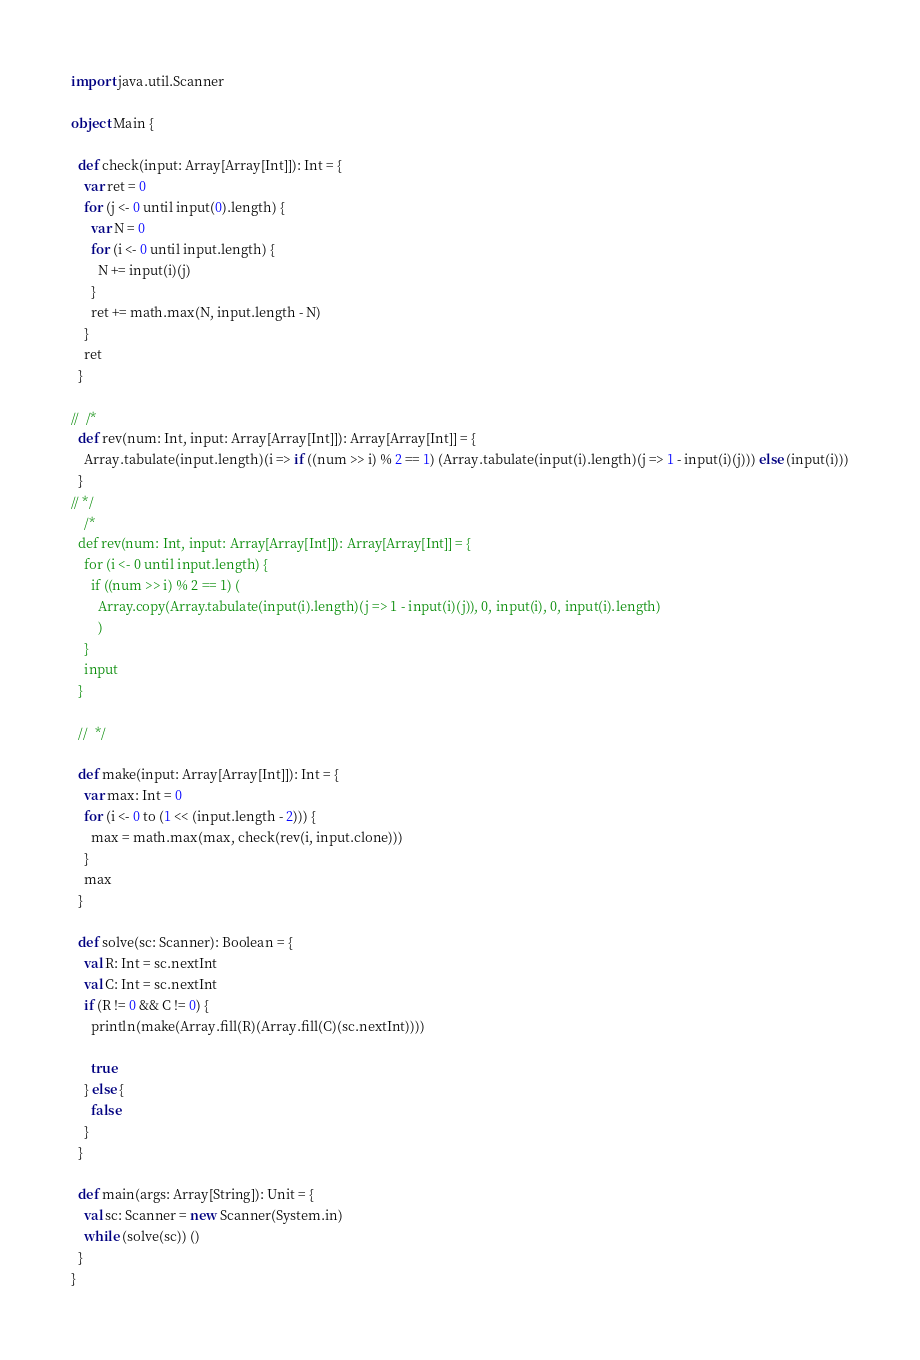<code> <loc_0><loc_0><loc_500><loc_500><_Scala_>import java.util.Scanner

object Main {

  def check(input: Array[Array[Int]]): Int = {
    var ret = 0
    for (j <- 0 until input(0).length) {
      var N = 0
      for (i <- 0 until input.length) {
        N += input(i)(j)
      }
      ret += math.max(N, input.length - N)
    }
    ret
  }

//  /*
  def rev(num: Int, input: Array[Array[Int]]): Array[Array[Int]] = {
    Array.tabulate(input.length)(i => if ((num >> i) % 2 == 1) (Array.tabulate(input(i).length)(j => 1 - input(i)(j))) else (input(i)))
  }
// */
    /*
  def rev(num: Int, input: Array[Array[Int]]): Array[Array[Int]] = {
    for (i <- 0 until input.length) {
      if ((num >> i) % 2 == 1) (
        Array.copy(Array.tabulate(input(i).length)(j => 1 - input(i)(j)), 0, input(i), 0, input(i).length)
        )
    }
    input
  }

  //  */

  def make(input: Array[Array[Int]]): Int = {
    var max: Int = 0
    for (i <- 0 to (1 << (input.length - 2))) {
      max = math.max(max, check(rev(i, input.clone)))
    }
    max
  }

  def solve(sc: Scanner): Boolean = {
    val R: Int = sc.nextInt
    val C: Int = sc.nextInt
    if (R != 0 && C != 0) {
      println(make(Array.fill(R)(Array.fill(C)(sc.nextInt))))

      true
    } else {
      false
    }
  }

  def main(args: Array[String]): Unit = {
    val sc: Scanner = new Scanner(System.in)
    while (solve(sc)) ()
  }
}</code> 